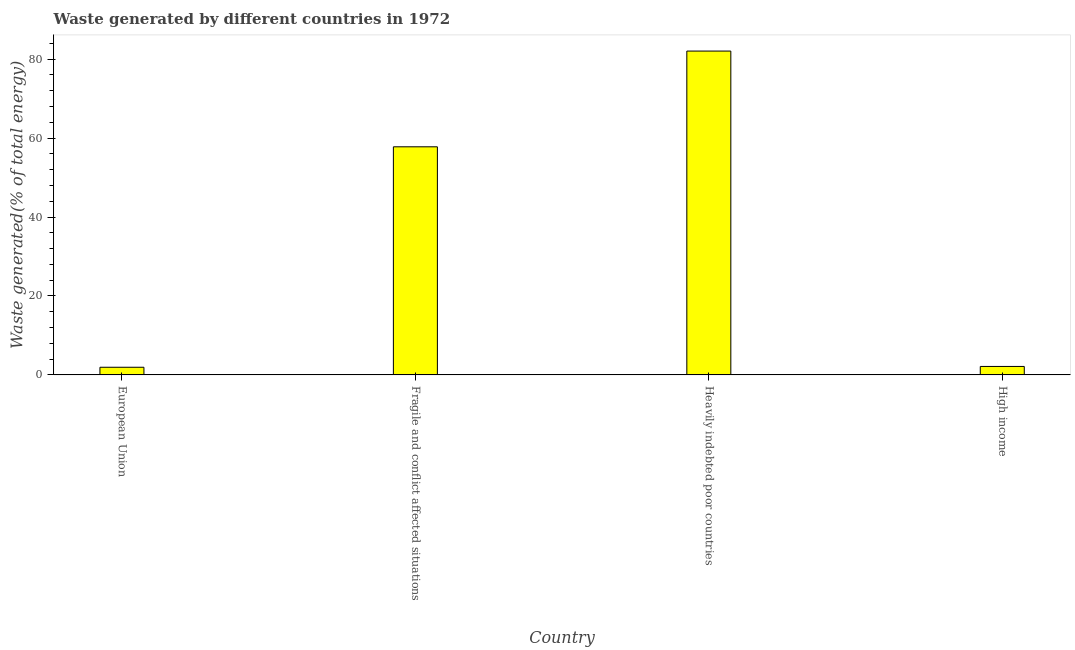Does the graph contain any zero values?
Your answer should be compact. No. What is the title of the graph?
Give a very brief answer. Waste generated by different countries in 1972. What is the label or title of the X-axis?
Keep it short and to the point. Country. What is the label or title of the Y-axis?
Offer a terse response. Waste generated(% of total energy). What is the amount of waste generated in High income?
Provide a short and direct response. 2.14. Across all countries, what is the maximum amount of waste generated?
Give a very brief answer. 82.05. Across all countries, what is the minimum amount of waste generated?
Offer a terse response. 1.94. In which country was the amount of waste generated maximum?
Provide a short and direct response. Heavily indebted poor countries. What is the sum of the amount of waste generated?
Keep it short and to the point. 143.92. What is the difference between the amount of waste generated in Fragile and conflict affected situations and High income?
Provide a succinct answer. 55.65. What is the average amount of waste generated per country?
Provide a succinct answer. 35.98. What is the median amount of waste generated?
Offer a very short reply. 29.97. What is the ratio of the amount of waste generated in Heavily indebted poor countries to that in High income?
Your answer should be very brief. 38.28. What is the difference between the highest and the second highest amount of waste generated?
Provide a succinct answer. 24.26. Is the sum of the amount of waste generated in European Union and Heavily indebted poor countries greater than the maximum amount of waste generated across all countries?
Offer a terse response. Yes. What is the difference between the highest and the lowest amount of waste generated?
Make the answer very short. 80.11. In how many countries, is the amount of waste generated greater than the average amount of waste generated taken over all countries?
Keep it short and to the point. 2. Are the values on the major ticks of Y-axis written in scientific E-notation?
Offer a terse response. No. What is the Waste generated(% of total energy) of European Union?
Your answer should be very brief. 1.94. What is the Waste generated(% of total energy) of Fragile and conflict affected situations?
Provide a short and direct response. 57.79. What is the Waste generated(% of total energy) in Heavily indebted poor countries?
Give a very brief answer. 82.05. What is the Waste generated(% of total energy) in High income?
Offer a very short reply. 2.14. What is the difference between the Waste generated(% of total energy) in European Union and Fragile and conflict affected situations?
Offer a terse response. -55.85. What is the difference between the Waste generated(% of total energy) in European Union and Heavily indebted poor countries?
Your response must be concise. -80.11. What is the difference between the Waste generated(% of total energy) in European Union and High income?
Offer a terse response. -0.2. What is the difference between the Waste generated(% of total energy) in Fragile and conflict affected situations and Heavily indebted poor countries?
Provide a succinct answer. -24.26. What is the difference between the Waste generated(% of total energy) in Fragile and conflict affected situations and High income?
Make the answer very short. 55.65. What is the difference between the Waste generated(% of total energy) in Heavily indebted poor countries and High income?
Offer a very short reply. 79.91. What is the ratio of the Waste generated(% of total energy) in European Union to that in Fragile and conflict affected situations?
Make the answer very short. 0.03. What is the ratio of the Waste generated(% of total energy) in European Union to that in Heavily indebted poor countries?
Provide a short and direct response. 0.02. What is the ratio of the Waste generated(% of total energy) in European Union to that in High income?
Your answer should be very brief. 0.91. What is the ratio of the Waste generated(% of total energy) in Fragile and conflict affected situations to that in Heavily indebted poor countries?
Give a very brief answer. 0.7. What is the ratio of the Waste generated(% of total energy) in Fragile and conflict affected situations to that in High income?
Give a very brief answer. 26.96. What is the ratio of the Waste generated(% of total energy) in Heavily indebted poor countries to that in High income?
Keep it short and to the point. 38.28. 